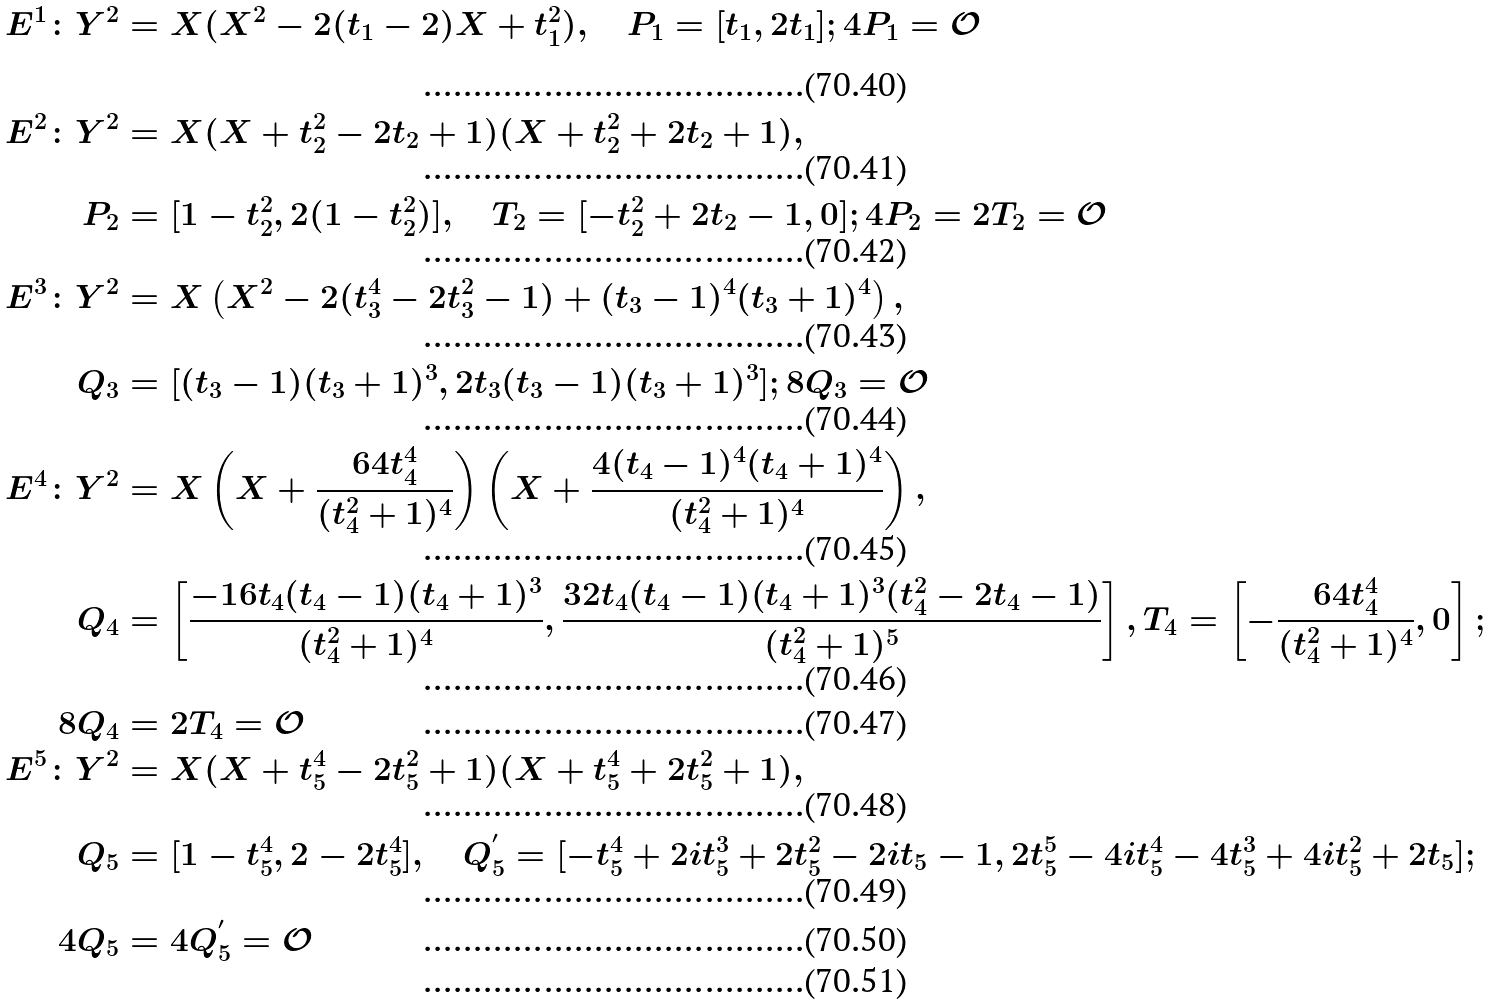Convert formula to latex. <formula><loc_0><loc_0><loc_500><loc_500>E ^ { 1 } \colon Y ^ { 2 } & = X ( X ^ { 2 } - 2 ( t _ { 1 } - 2 ) X + t _ { 1 } ^ { 2 } ) , \quad P _ { 1 } = [ t _ { 1 } , 2 t _ { 1 } ] ; 4 P _ { 1 } = \mathcal { O } \\ E ^ { 2 } \colon Y ^ { 2 } & = X ( X + t _ { 2 } ^ { 2 } - 2 t _ { 2 } + 1 ) ( X + t _ { 2 } ^ { 2 } + 2 t _ { 2 } + 1 ) , \\ P _ { 2 } & = [ 1 - t _ { 2 } ^ { 2 } , 2 ( 1 - t _ { 2 } ^ { 2 } ) ] , \quad T _ { 2 } = [ - t _ { 2 } ^ { 2 } + 2 t _ { 2 } - 1 , 0 ] ; 4 P _ { 2 } = 2 T _ { 2 } = \mathcal { O } \\ E ^ { 3 } \colon Y ^ { 2 } & = X \left ( X ^ { 2 } - 2 ( t _ { 3 } ^ { 4 } - 2 t _ { 3 } ^ { 2 } - 1 ) + ( t _ { 3 } - 1 ) ^ { 4 } ( t _ { 3 } + 1 ) ^ { 4 } \right ) , \\ Q _ { 3 } & = [ ( t _ { 3 } - 1 ) ( t _ { 3 } + 1 ) ^ { 3 } , 2 t _ { 3 } ( t _ { 3 } - 1 ) ( t _ { 3 } + 1 ) ^ { 3 } ] ; 8 Q _ { 3 } = \mathcal { O } \\ E ^ { 4 } \colon Y ^ { 2 } & = X \left ( X + \frac { 6 4 t _ { 4 } ^ { 4 } } { ( t _ { 4 } ^ { 2 } + 1 ) ^ { 4 } } \right ) \left ( X + \frac { 4 ( t _ { 4 } - 1 ) ^ { 4 } ( t _ { 4 } + 1 ) ^ { 4 } } { ( t _ { 4 } ^ { 2 } + 1 ) ^ { 4 } } \right ) , \\ Q _ { 4 } & = \left [ \frac { - 1 6 t _ { 4 } ( t _ { 4 } - 1 ) ( t _ { 4 } + 1 ) ^ { 3 } } { ( t _ { 4 } ^ { 2 } + 1 ) ^ { 4 } } , \frac { 3 2 t _ { 4 } ( t _ { 4 } - 1 ) ( t _ { 4 } + 1 ) ^ { 3 } ( t _ { 4 } ^ { 2 } - 2 t _ { 4 } - 1 ) } { ( t _ { 4 } ^ { 2 } + 1 ) ^ { 5 } } \right ] , T _ { 4 } = \left [ - \frac { 6 4 t _ { 4 } ^ { 4 } } { ( t _ { 4 } ^ { 2 } + 1 ) ^ { 4 } } , 0 \right ] ; \\ 8 Q _ { 4 } & = 2 T _ { 4 } = \mathcal { O } \\ E ^ { 5 } \colon Y ^ { 2 } & = X ( X + t _ { 5 } ^ { 4 } - 2 t _ { 5 } ^ { 2 } + 1 ) ( X + t _ { 5 } ^ { 4 } + 2 t _ { 5 } ^ { 2 } + 1 ) , \\ Q _ { 5 } & = [ 1 - t _ { 5 } ^ { 4 } , 2 - 2 t _ { 5 } ^ { 4 } ] , \quad Q ^ { ^ { \prime } } _ { 5 } = [ - t _ { 5 } ^ { 4 } + 2 i t _ { 5 } ^ { 3 } + 2 t _ { 5 } ^ { 2 } - 2 i t _ { 5 } - 1 , 2 t _ { 5 } ^ { 5 } - 4 i t _ { 5 } ^ { 4 } - 4 t _ { 5 } ^ { 3 } + 4 i t _ { 5 } ^ { 2 } + 2 t _ { 5 } ] ; \\ 4 Q _ { 5 } & = 4 Q _ { 5 } ^ { ^ { \prime } } = \mathcal { O } \\</formula> 